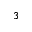Convert formula to latex. <formula><loc_0><loc_0><loc_500><loc_500>^ { 3 }</formula> 